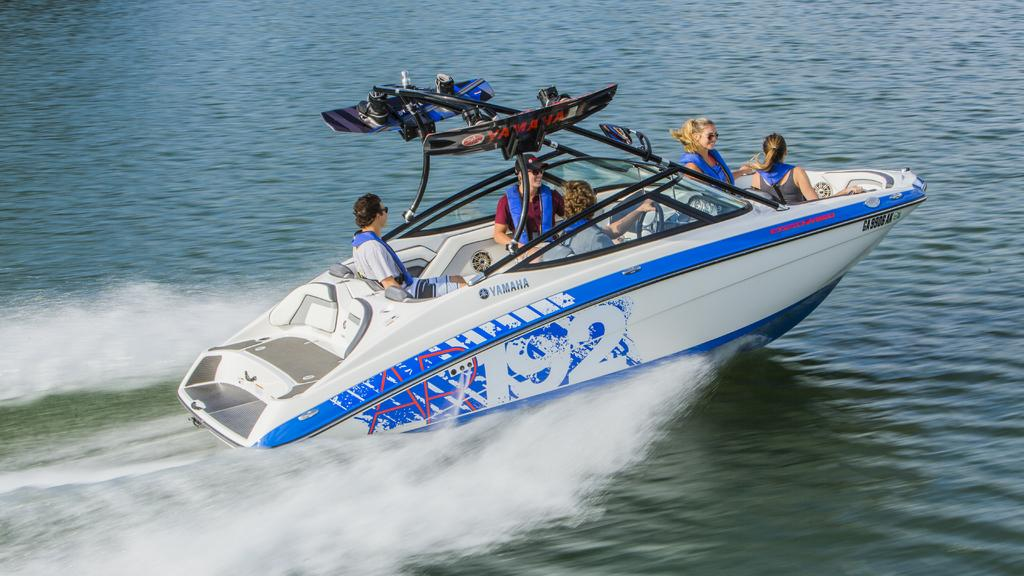Who or what can be seen in the image? There are people in the image. What are the people doing in the image? The people are sitting on a boat. Can you describe the boat in the image? The boat is white in color. Where is the boat located in the image? The boat is on the water. What is the name of the ink used to write the facts about the image? There is no ink or writing present in the image, so it is not possible to determine the name of the ink used. 